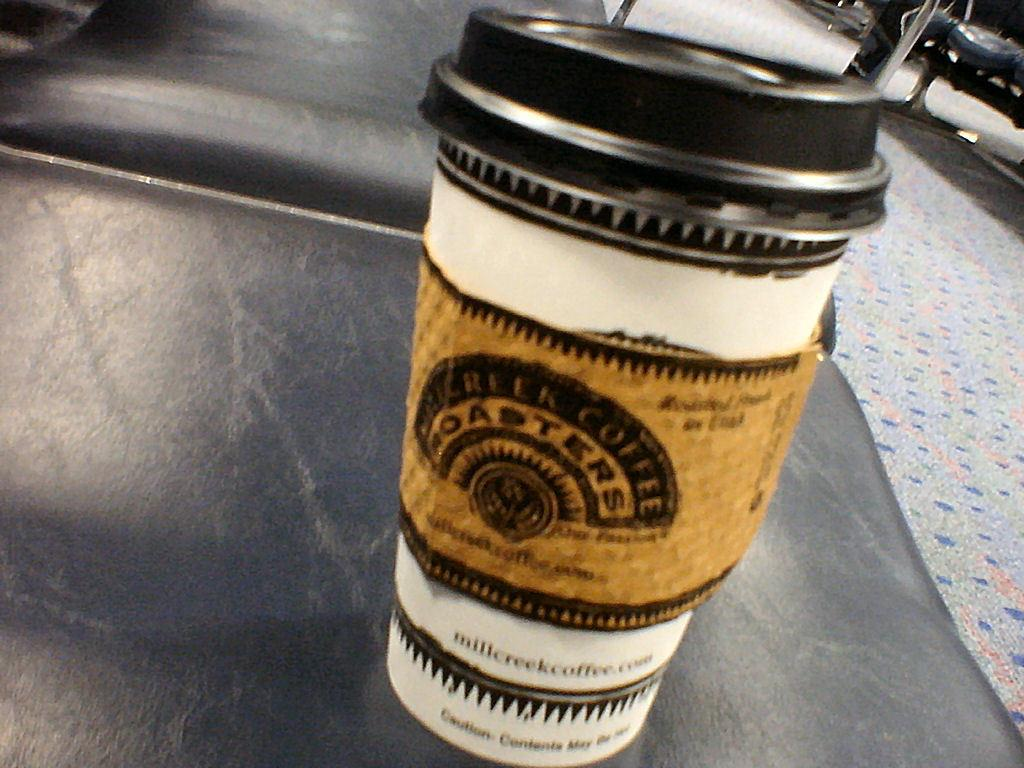<image>
Give a short and clear explanation of the subsequent image. a white and black coffee cup with a brown sleeve labeled roasters on it 